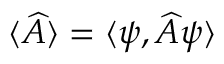Convert formula to latex. <formula><loc_0><loc_0><loc_500><loc_500>\langle \widehat { A } \rangle = \langle \psi , \widehat { A } \psi \rangle</formula> 